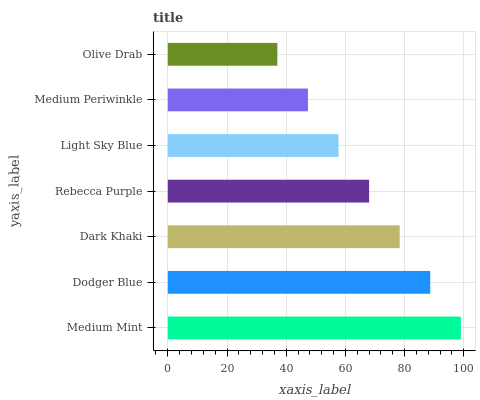Is Olive Drab the minimum?
Answer yes or no. Yes. Is Medium Mint the maximum?
Answer yes or no. Yes. Is Dodger Blue the minimum?
Answer yes or no. No. Is Dodger Blue the maximum?
Answer yes or no. No. Is Medium Mint greater than Dodger Blue?
Answer yes or no. Yes. Is Dodger Blue less than Medium Mint?
Answer yes or no. Yes. Is Dodger Blue greater than Medium Mint?
Answer yes or no. No. Is Medium Mint less than Dodger Blue?
Answer yes or no. No. Is Rebecca Purple the high median?
Answer yes or no. Yes. Is Rebecca Purple the low median?
Answer yes or no. Yes. Is Dodger Blue the high median?
Answer yes or no. No. Is Light Sky Blue the low median?
Answer yes or no. No. 